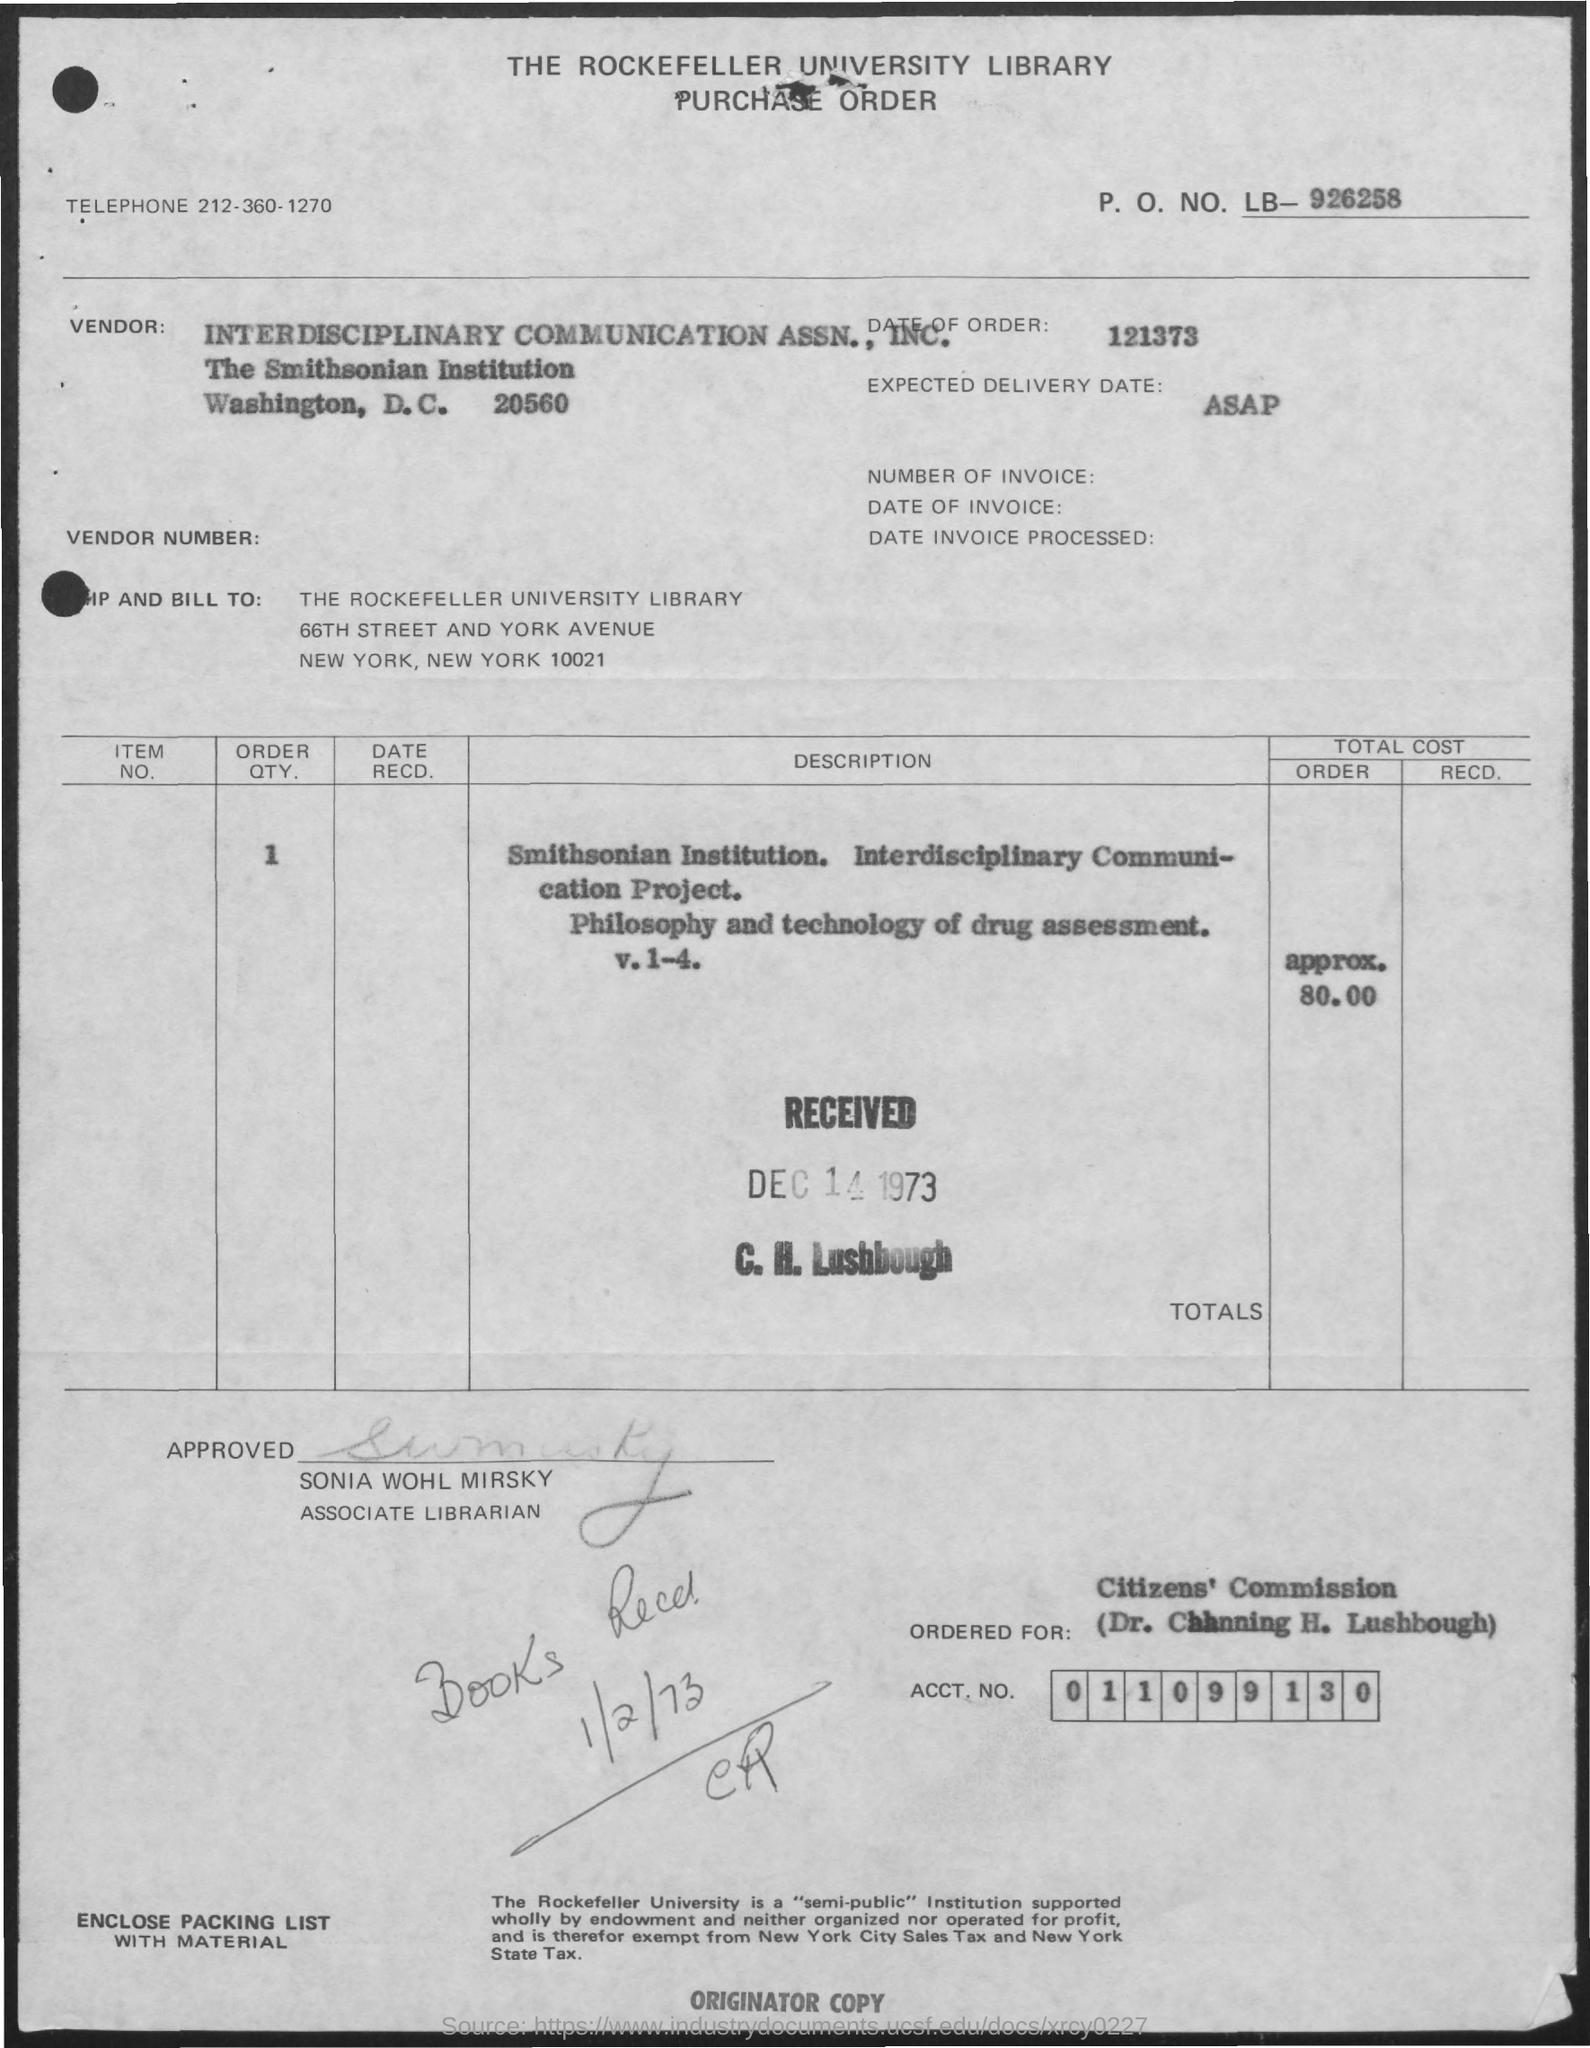Mention a couple of crucial points in this snapshot. The expected delivery date is ASAP. On the date of January 2, 1973, the books were received. The associate librarian's name is Sonia Wohl Mirsky. The approximate total cost of the order is approximately 80.00. The telephone number is 212-360-1270. 